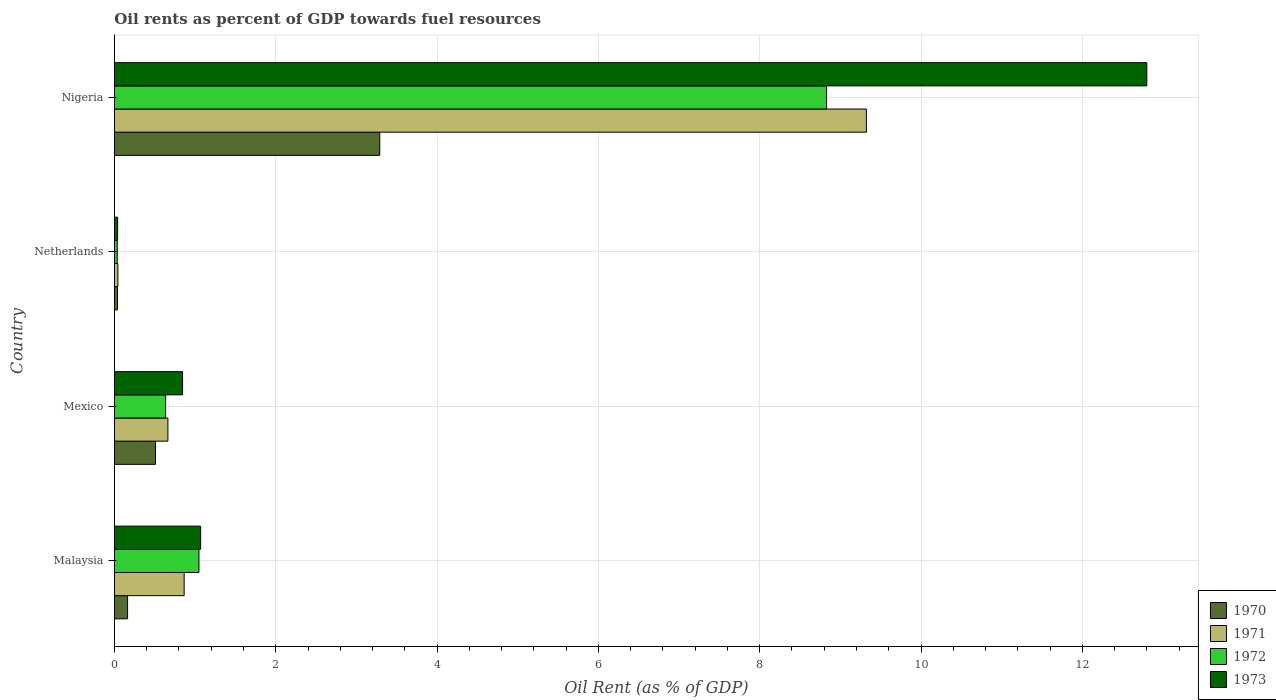Are the number of bars on each tick of the Y-axis equal?
Offer a terse response. Yes. How many bars are there on the 4th tick from the top?
Give a very brief answer. 4. How many bars are there on the 4th tick from the bottom?
Provide a short and direct response. 4. In how many cases, is the number of bars for a given country not equal to the number of legend labels?
Ensure brevity in your answer.  0. What is the oil rent in 1972 in Malaysia?
Your answer should be very brief. 1.05. Across all countries, what is the maximum oil rent in 1972?
Your answer should be compact. 8.83. Across all countries, what is the minimum oil rent in 1973?
Your answer should be very brief. 0.04. In which country was the oil rent in 1972 maximum?
Your answer should be compact. Nigeria. What is the total oil rent in 1970 in the graph?
Keep it short and to the point. 4. What is the difference between the oil rent in 1971 in Malaysia and that in Nigeria?
Your response must be concise. -8.46. What is the difference between the oil rent in 1970 in Nigeria and the oil rent in 1973 in Malaysia?
Your answer should be compact. 2.22. What is the average oil rent in 1973 per country?
Offer a very short reply. 3.69. What is the difference between the oil rent in 1971 and oil rent in 1970 in Netherlands?
Offer a very short reply. 0.01. What is the ratio of the oil rent in 1972 in Mexico to that in Netherlands?
Give a very brief answer. 18.28. Is the oil rent in 1973 in Netherlands less than that in Nigeria?
Offer a very short reply. Yes. What is the difference between the highest and the second highest oil rent in 1973?
Provide a succinct answer. 11.73. What is the difference between the highest and the lowest oil rent in 1973?
Provide a succinct answer. 12.76. Is the sum of the oil rent in 1971 in Malaysia and Netherlands greater than the maximum oil rent in 1972 across all countries?
Provide a short and direct response. No. What does the 3rd bar from the bottom in Nigeria represents?
Give a very brief answer. 1972. How many countries are there in the graph?
Make the answer very short. 4. What is the difference between two consecutive major ticks on the X-axis?
Offer a terse response. 2. Does the graph contain grids?
Provide a succinct answer. Yes. Where does the legend appear in the graph?
Offer a very short reply. Bottom right. What is the title of the graph?
Give a very brief answer. Oil rents as percent of GDP towards fuel resources. Does "2014" appear as one of the legend labels in the graph?
Your answer should be compact. No. What is the label or title of the X-axis?
Offer a terse response. Oil Rent (as % of GDP). What is the label or title of the Y-axis?
Your answer should be very brief. Country. What is the Oil Rent (as % of GDP) of 1970 in Malaysia?
Make the answer very short. 0.16. What is the Oil Rent (as % of GDP) in 1971 in Malaysia?
Your answer should be compact. 0.86. What is the Oil Rent (as % of GDP) in 1972 in Malaysia?
Keep it short and to the point. 1.05. What is the Oil Rent (as % of GDP) in 1973 in Malaysia?
Offer a very short reply. 1.07. What is the Oil Rent (as % of GDP) of 1970 in Mexico?
Your answer should be very brief. 0.51. What is the Oil Rent (as % of GDP) of 1971 in Mexico?
Provide a succinct answer. 0.66. What is the Oil Rent (as % of GDP) in 1972 in Mexico?
Your answer should be very brief. 0.63. What is the Oil Rent (as % of GDP) in 1973 in Mexico?
Your answer should be very brief. 0.84. What is the Oil Rent (as % of GDP) of 1970 in Netherlands?
Your response must be concise. 0.04. What is the Oil Rent (as % of GDP) in 1971 in Netherlands?
Keep it short and to the point. 0.04. What is the Oil Rent (as % of GDP) in 1972 in Netherlands?
Provide a succinct answer. 0.03. What is the Oil Rent (as % of GDP) in 1973 in Netherlands?
Provide a succinct answer. 0.04. What is the Oil Rent (as % of GDP) of 1970 in Nigeria?
Provide a short and direct response. 3.29. What is the Oil Rent (as % of GDP) in 1971 in Nigeria?
Ensure brevity in your answer.  9.32. What is the Oil Rent (as % of GDP) of 1972 in Nigeria?
Give a very brief answer. 8.83. What is the Oil Rent (as % of GDP) in 1973 in Nigeria?
Make the answer very short. 12.8. Across all countries, what is the maximum Oil Rent (as % of GDP) of 1970?
Make the answer very short. 3.29. Across all countries, what is the maximum Oil Rent (as % of GDP) in 1971?
Give a very brief answer. 9.32. Across all countries, what is the maximum Oil Rent (as % of GDP) of 1972?
Give a very brief answer. 8.83. Across all countries, what is the maximum Oil Rent (as % of GDP) in 1973?
Ensure brevity in your answer.  12.8. Across all countries, what is the minimum Oil Rent (as % of GDP) in 1970?
Offer a terse response. 0.04. Across all countries, what is the minimum Oil Rent (as % of GDP) of 1971?
Offer a very short reply. 0.04. Across all countries, what is the minimum Oil Rent (as % of GDP) of 1972?
Offer a terse response. 0.03. Across all countries, what is the minimum Oil Rent (as % of GDP) of 1973?
Offer a very short reply. 0.04. What is the total Oil Rent (as % of GDP) of 1970 in the graph?
Ensure brevity in your answer.  4. What is the total Oil Rent (as % of GDP) in 1971 in the graph?
Offer a terse response. 10.89. What is the total Oil Rent (as % of GDP) of 1972 in the graph?
Offer a very short reply. 10.55. What is the total Oil Rent (as % of GDP) of 1973 in the graph?
Ensure brevity in your answer.  14.75. What is the difference between the Oil Rent (as % of GDP) in 1970 in Malaysia and that in Mexico?
Provide a short and direct response. -0.35. What is the difference between the Oil Rent (as % of GDP) in 1971 in Malaysia and that in Mexico?
Provide a succinct answer. 0.2. What is the difference between the Oil Rent (as % of GDP) in 1972 in Malaysia and that in Mexico?
Offer a terse response. 0.41. What is the difference between the Oil Rent (as % of GDP) of 1973 in Malaysia and that in Mexico?
Provide a succinct answer. 0.22. What is the difference between the Oil Rent (as % of GDP) of 1970 in Malaysia and that in Netherlands?
Offer a very short reply. 0.13. What is the difference between the Oil Rent (as % of GDP) in 1971 in Malaysia and that in Netherlands?
Offer a very short reply. 0.82. What is the difference between the Oil Rent (as % of GDP) of 1972 in Malaysia and that in Netherlands?
Your answer should be very brief. 1.01. What is the difference between the Oil Rent (as % of GDP) of 1973 in Malaysia and that in Netherlands?
Keep it short and to the point. 1.03. What is the difference between the Oil Rent (as % of GDP) of 1970 in Malaysia and that in Nigeria?
Your response must be concise. -3.13. What is the difference between the Oil Rent (as % of GDP) of 1971 in Malaysia and that in Nigeria?
Ensure brevity in your answer.  -8.46. What is the difference between the Oil Rent (as % of GDP) in 1972 in Malaysia and that in Nigeria?
Your answer should be very brief. -7.78. What is the difference between the Oil Rent (as % of GDP) in 1973 in Malaysia and that in Nigeria?
Make the answer very short. -11.73. What is the difference between the Oil Rent (as % of GDP) of 1970 in Mexico and that in Netherlands?
Keep it short and to the point. 0.47. What is the difference between the Oil Rent (as % of GDP) in 1971 in Mexico and that in Netherlands?
Keep it short and to the point. 0.62. What is the difference between the Oil Rent (as % of GDP) in 1972 in Mexico and that in Netherlands?
Provide a succinct answer. 0.6. What is the difference between the Oil Rent (as % of GDP) in 1973 in Mexico and that in Netherlands?
Your response must be concise. 0.81. What is the difference between the Oil Rent (as % of GDP) in 1970 in Mexico and that in Nigeria?
Make the answer very short. -2.78. What is the difference between the Oil Rent (as % of GDP) of 1971 in Mexico and that in Nigeria?
Provide a succinct answer. -8.66. What is the difference between the Oil Rent (as % of GDP) of 1972 in Mexico and that in Nigeria?
Offer a very short reply. -8.19. What is the difference between the Oil Rent (as % of GDP) of 1973 in Mexico and that in Nigeria?
Offer a very short reply. -11.95. What is the difference between the Oil Rent (as % of GDP) of 1970 in Netherlands and that in Nigeria?
Offer a very short reply. -3.25. What is the difference between the Oil Rent (as % of GDP) in 1971 in Netherlands and that in Nigeria?
Your answer should be very brief. -9.28. What is the difference between the Oil Rent (as % of GDP) of 1972 in Netherlands and that in Nigeria?
Your response must be concise. -8.79. What is the difference between the Oil Rent (as % of GDP) in 1973 in Netherlands and that in Nigeria?
Make the answer very short. -12.76. What is the difference between the Oil Rent (as % of GDP) in 1970 in Malaysia and the Oil Rent (as % of GDP) in 1971 in Mexico?
Your answer should be compact. -0.5. What is the difference between the Oil Rent (as % of GDP) in 1970 in Malaysia and the Oil Rent (as % of GDP) in 1972 in Mexico?
Ensure brevity in your answer.  -0.47. What is the difference between the Oil Rent (as % of GDP) in 1970 in Malaysia and the Oil Rent (as % of GDP) in 1973 in Mexico?
Your answer should be very brief. -0.68. What is the difference between the Oil Rent (as % of GDP) in 1971 in Malaysia and the Oil Rent (as % of GDP) in 1972 in Mexico?
Provide a short and direct response. 0.23. What is the difference between the Oil Rent (as % of GDP) in 1971 in Malaysia and the Oil Rent (as % of GDP) in 1973 in Mexico?
Ensure brevity in your answer.  0.02. What is the difference between the Oil Rent (as % of GDP) in 1972 in Malaysia and the Oil Rent (as % of GDP) in 1973 in Mexico?
Offer a terse response. 0.2. What is the difference between the Oil Rent (as % of GDP) of 1970 in Malaysia and the Oil Rent (as % of GDP) of 1971 in Netherlands?
Make the answer very short. 0.12. What is the difference between the Oil Rent (as % of GDP) in 1970 in Malaysia and the Oil Rent (as % of GDP) in 1972 in Netherlands?
Your answer should be very brief. 0.13. What is the difference between the Oil Rent (as % of GDP) of 1970 in Malaysia and the Oil Rent (as % of GDP) of 1973 in Netherlands?
Keep it short and to the point. 0.12. What is the difference between the Oil Rent (as % of GDP) in 1971 in Malaysia and the Oil Rent (as % of GDP) in 1972 in Netherlands?
Make the answer very short. 0.83. What is the difference between the Oil Rent (as % of GDP) in 1971 in Malaysia and the Oil Rent (as % of GDP) in 1973 in Netherlands?
Offer a terse response. 0.82. What is the difference between the Oil Rent (as % of GDP) in 1972 in Malaysia and the Oil Rent (as % of GDP) in 1973 in Netherlands?
Your answer should be very brief. 1.01. What is the difference between the Oil Rent (as % of GDP) in 1970 in Malaysia and the Oil Rent (as % of GDP) in 1971 in Nigeria?
Offer a terse response. -9.16. What is the difference between the Oil Rent (as % of GDP) in 1970 in Malaysia and the Oil Rent (as % of GDP) in 1972 in Nigeria?
Your answer should be compact. -8.67. What is the difference between the Oil Rent (as % of GDP) in 1970 in Malaysia and the Oil Rent (as % of GDP) in 1973 in Nigeria?
Your answer should be very brief. -12.64. What is the difference between the Oil Rent (as % of GDP) of 1971 in Malaysia and the Oil Rent (as % of GDP) of 1972 in Nigeria?
Provide a succinct answer. -7.96. What is the difference between the Oil Rent (as % of GDP) in 1971 in Malaysia and the Oil Rent (as % of GDP) in 1973 in Nigeria?
Provide a short and direct response. -11.94. What is the difference between the Oil Rent (as % of GDP) of 1972 in Malaysia and the Oil Rent (as % of GDP) of 1973 in Nigeria?
Give a very brief answer. -11.75. What is the difference between the Oil Rent (as % of GDP) in 1970 in Mexico and the Oil Rent (as % of GDP) in 1971 in Netherlands?
Provide a short and direct response. 0.47. What is the difference between the Oil Rent (as % of GDP) of 1970 in Mexico and the Oil Rent (as % of GDP) of 1972 in Netherlands?
Your answer should be compact. 0.47. What is the difference between the Oil Rent (as % of GDP) in 1970 in Mexico and the Oil Rent (as % of GDP) in 1973 in Netherlands?
Offer a very short reply. 0.47. What is the difference between the Oil Rent (as % of GDP) in 1971 in Mexico and the Oil Rent (as % of GDP) in 1972 in Netherlands?
Your answer should be compact. 0.63. What is the difference between the Oil Rent (as % of GDP) of 1971 in Mexico and the Oil Rent (as % of GDP) of 1973 in Netherlands?
Offer a terse response. 0.62. What is the difference between the Oil Rent (as % of GDP) of 1972 in Mexico and the Oil Rent (as % of GDP) of 1973 in Netherlands?
Your answer should be compact. 0.6. What is the difference between the Oil Rent (as % of GDP) in 1970 in Mexico and the Oil Rent (as % of GDP) in 1971 in Nigeria?
Keep it short and to the point. -8.81. What is the difference between the Oil Rent (as % of GDP) in 1970 in Mexico and the Oil Rent (as % of GDP) in 1972 in Nigeria?
Offer a terse response. -8.32. What is the difference between the Oil Rent (as % of GDP) of 1970 in Mexico and the Oil Rent (as % of GDP) of 1973 in Nigeria?
Keep it short and to the point. -12.29. What is the difference between the Oil Rent (as % of GDP) in 1971 in Mexico and the Oil Rent (as % of GDP) in 1972 in Nigeria?
Offer a terse response. -8.17. What is the difference between the Oil Rent (as % of GDP) of 1971 in Mexico and the Oil Rent (as % of GDP) of 1973 in Nigeria?
Ensure brevity in your answer.  -12.14. What is the difference between the Oil Rent (as % of GDP) in 1972 in Mexico and the Oil Rent (as % of GDP) in 1973 in Nigeria?
Your response must be concise. -12.16. What is the difference between the Oil Rent (as % of GDP) of 1970 in Netherlands and the Oil Rent (as % of GDP) of 1971 in Nigeria?
Give a very brief answer. -9.29. What is the difference between the Oil Rent (as % of GDP) of 1970 in Netherlands and the Oil Rent (as % of GDP) of 1972 in Nigeria?
Offer a very short reply. -8.79. What is the difference between the Oil Rent (as % of GDP) in 1970 in Netherlands and the Oil Rent (as % of GDP) in 1973 in Nigeria?
Offer a terse response. -12.76. What is the difference between the Oil Rent (as % of GDP) in 1971 in Netherlands and the Oil Rent (as % of GDP) in 1972 in Nigeria?
Give a very brief answer. -8.79. What is the difference between the Oil Rent (as % of GDP) of 1971 in Netherlands and the Oil Rent (as % of GDP) of 1973 in Nigeria?
Your answer should be compact. -12.76. What is the difference between the Oil Rent (as % of GDP) in 1972 in Netherlands and the Oil Rent (as % of GDP) in 1973 in Nigeria?
Keep it short and to the point. -12.76. What is the average Oil Rent (as % of GDP) of 1971 per country?
Give a very brief answer. 2.72. What is the average Oil Rent (as % of GDP) in 1972 per country?
Your response must be concise. 2.64. What is the average Oil Rent (as % of GDP) in 1973 per country?
Your response must be concise. 3.69. What is the difference between the Oil Rent (as % of GDP) in 1970 and Oil Rent (as % of GDP) in 1971 in Malaysia?
Offer a very short reply. -0.7. What is the difference between the Oil Rent (as % of GDP) in 1970 and Oil Rent (as % of GDP) in 1972 in Malaysia?
Offer a terse response. -0.89. What is the difference between the Oil Rent (as % of GDP) in 1970 and Oil Rent (as % of GDP) in 1973 in Malaysia?
Make the answer very short. -0.91. What is the difference between the Oil Rent (as % of GDP) in 1971 and Oil Rent (as % of GDP) in 1972 in Malaysia?
Give a very brief answer. -0.18. What is the difference between the Oil Rent (as % of GDP) in 1971 and Oil Rent (as % of GDP) in 1973 in Malaysia?
Make the answer very short. -0.2. What is the difference between the Oil Rent (as % of GDP) in 1972 and Oil Rent (as % of GDP) in 1973 in Malaysia?
Ensure brevity in your answer.  -0.02. What is the difference between the Oil Rent (as % of GDP) in 1970 and Oil Rent (as % of GDP) in 1971 in Mexico?
Give a very brief answer. -0.15. What is the difference between the Oil Rent (as % of GDP) of 1970 and Oil Rent (as % of GDP) of 1972 in Mexico?
Offer a terse response. -0.13. What is the difference between the Oil Rent (as % of GDP) of 1970 and Oil Rent (as % of GDP) of 1973 in Mexico?
Your response must be concise. -0.34. What is the difference between the Oil Rent (as % of GDP) in 1971 and Oil Rent (as % of GDP) in 1972 in Mexico?
Provide a short and direct response. 0.03. What is the difference between the Oil Rent (as % of GDP) of 1971 and Oil Rent (as % of GDP) of 1973 in Mexico?
Give a very brief answer. -0.18. What is the difference between the Oil Rent (as % of GDP) of 1972 and Oil Rent (as % of GDP) of 1973 in Mexico?
Make the answer very short. -0.21. What is the difference between the Oil Rent (as % of GDP) of 1970 and Oil Rent (as % of GDP) of 1971 in Netherlands?
Offer a very short reply. -0.01. What is the difference between the Oil Rent (as % of GDP) of 1970 and Oil Rent (as % of GDP) of 1972 in Netherlands?
Your answer should be compact. 0. What is the difference between the Oil Rent (as % of GDP) in 1970 and Oil Rent (as % of GDP) in 1973 in Netherlands?
Ensure brevity in your answer.  -0. What is the difference between the Oil Rent (as % of GDP) of 1971 and Oil Rent (as % of GDP) of 1972 in Netherlands?
Your response must be concise. 0.01. What is the difference between the Oil Rent (as % of GDP) in 1971 and Oil Rent (as % of GDP) in 1973 in Netherlands?
Give a very brief answer. 0. What is the difference between the Oil Rent (as % of GDP) in 1972 and Oil Rent (as % of GDP) in 1973 in Netherlands?
Ensure brevity in your answer.  -0. What is the difference between the Oil Rent (as % of GDP) of 1970 and Oil Rent (as % of GDP) of 1971 in Nigeria?
Your response must be concise. -6.03. What is the difference between the Oil Rent (as % of GDP) of 1970 and Oil Rent (as % of GDP) of 1972 in Nigeria?
Offer a terse response. -5.54. What is the difference between the Oil Rent (as % of GDP) in 1970 and Oil Rent (as % of GDP) in 1973 in Nigeria?
Make the answer very short. -9.51. What is the difference between the Oil Rent (as % of GDP) of 1971 and Oil Rent (as % of GDP) of 1972 in Nigeria?
Your answer should be compact. 0.49. What is the difference between the Oil Rent (as % of GDP) in 1971 and Oil Rent (as % of GDP) in 1973 in Nigeria?
Make the answer very short. -3.48. What is the difference between the Oil Rent (as % of GDP) in 1972 and Oil Rent (as % of GDP) in 1973 in Nigeria?
Give a very brief answer. -3.97. What is the ratio of the Oil Rent (as % of GDP) of 1970 in Malaysia to that in Mexico?
Your answer should be very brief. 0.32. What is the ratio of the Oil Rent (as % of GDP) of 1971 in Malaysia to that in Mexico?
Offer a terse response. 1.3. What is the ratio of the Oil Rent (as % of GDP) in 1972 in Malaysia to that in Mexico?
Provide a short and direct response. 1.65. What is the ratio of the Oil Rent (as % of GDP) in 1973 in Malaysia to that in Mexico?
Make the answer very short. 1.27. What is the ratio of the Oil Rent (as % of GDP) of 1970 in Malaysia to that in Netherlands?
Offer a terse response. 4.3. What is the ratio of the Oil Rent (as % of GDP) of 1971 in Malaysia to that in Netherlands?
Offer a terse response. 20.04. What is the ratio of the Oil Rent (as % of GDP) of 1972 in Malaysia to that in Netherlands?
Provide a succinct answer. 30.19. What is the ratio of the Oil Rent (as % of GDP) in 1973 in Malaysia to that in Netherlands?
Give a very brief answer. 27.06. What is the ratio of the Oil Rent (as % of GDP) in 1970 in Malaysia to that in Nigeria?
Offer a terse response. 0.05. What is the ratio of the Oil Rent (as % of GDP) of 1971 in Malaysia to that in Nigeria?
Provide a short and direct response. 0.09. What is the ratio of the Oil Rent (as % of GDP) of 1972 in Malaysia to that in Nigeria?
Offer a very short reply. 0.12. What is the ratio of the Oil Rent (as % of GDP) of 1973 in Malaysia to that in Nigeria?
Offer a very short reply. 0.08. What is the ratio of the Oil Rent (as % of GDP) in 1970 in Mexico to that in Netherlands?
Offer a very short reply. 13.43. What is the ratio of the Oil Rent (as % of GDP) of 1971 in Mexico to that in Netherlands?
Provide a succinct answer. 15.37. What is the ratio of the Oil Rent (as % of GDP) of 1972 in Mexico to that in Netherlands?
Your response must be concise. 18.28. What is the ratio of the Oil Rent (as % of GDP) in 1973 in Mexico to that in Netherlands?
Offer a terse response. 21.38. What is the ratio of the Oil Rent (as % of GDP) in 1970 in Mexico to that in Nigeria?
Make the answer very short. 0.15. What is the ratio of the Oil Rent (as % of GDP) in 1971 in Mexico to that in Nigeria?
Your answer should be very brief. 0.07. What is the ratio of the Oil Rent (as % of GDP) of 1972 in Mexico to that in Nigeria?
Offer a very short reply. 0.07. What is the ratio of the Oil Rent (as % of GDP) in 1973 in Mexico to that in Nigeria?
Offer a terse response. 0.07. What is the ratio of the Oil Rent (as % of GDP) of 1970 in Netherlands to that in Nigeria?
Your answer should be compact. 0.01. What is the ratio of the Oil Rent (as % of GDP) in 1971 in Netherlands to that in Nigeria?
Give a very brief answer. 0. What is the ratio of the Oil Rent (as % of GDP) in 1972 in Netherlands to that in Nigeria?
Give a very brief answer. 0. What is the ratio of the Oil Rent (as % of GDP) in 1973 in Netherlands to that in Nigeria?
Offer a very short reply. 0. What is the difference between the highest and the second highest Oil Rent (as % of GDP) of 1970?
Your answer should be compact. 2.78. What is the difference between the highest and the second highest Oil Rent (as % of GDP) in 1971?
Give a very brief answer. 8.46. What is the difference between the highest and the second highest Oil Rent (as % of GDP) in 1972?
Offer a terse response. 7.78. What is the difference between the highest and the second highest Oil Rent (as % of GDP) of 1973?
Make the answer very short. 11.73. What is the difference between the highest and the lowest Oil Rent (as % of GDP) in 1970?
Offer a very short reply. 3.25. What is the difference between the highest and the lowest Oil Rent (as % of GDP) of 1971?
Make the answer very short. 9.28. What is the difference between the highest and the lowest Oil Rent (as % of GDP) of 1972?
Make the answer very short. 8.79. What is the difference between the highest and the lowest Oil Rent (as % of GDP) in 1973?
Keep it short and to the point. 12.76. 